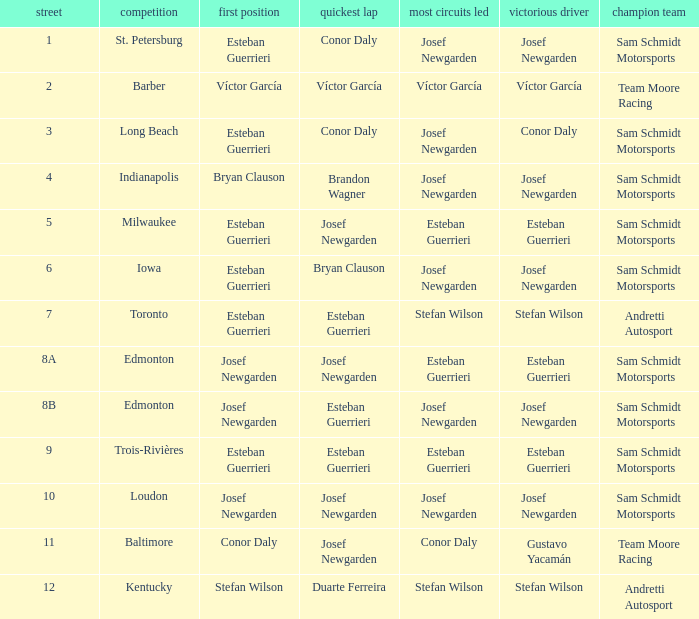What race did josef newgarden have the fastest lap and lead the most laps? Loudon. 